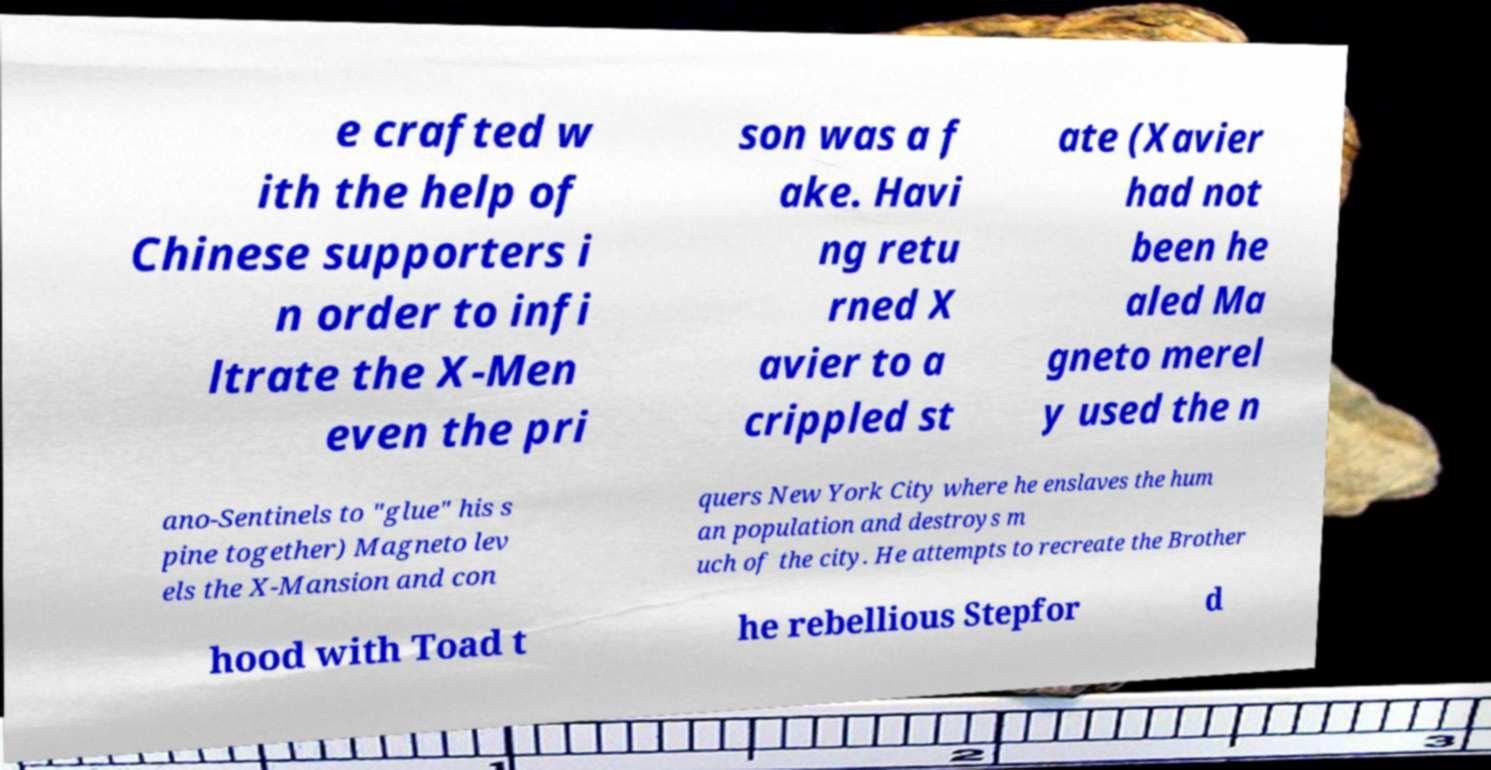Please identify and transcribe the text found in this image. e crafted w ith the help of Chinese supporters i n order to infi ltrate the X-Men even the pri son was a f ake. Havi ng retu rned X avier to a crippled st ate (Xavier had not been he aled Ma gneto merel y used the n ano-Sentinels to "glue" his s pine together) Magneto lev els the X-Mansion and con quers New York City where he enslaves the hum an population and destroys m uch of the city. He attempts to recreate the Brother hood with Toad t he rebellious Stepfor d 